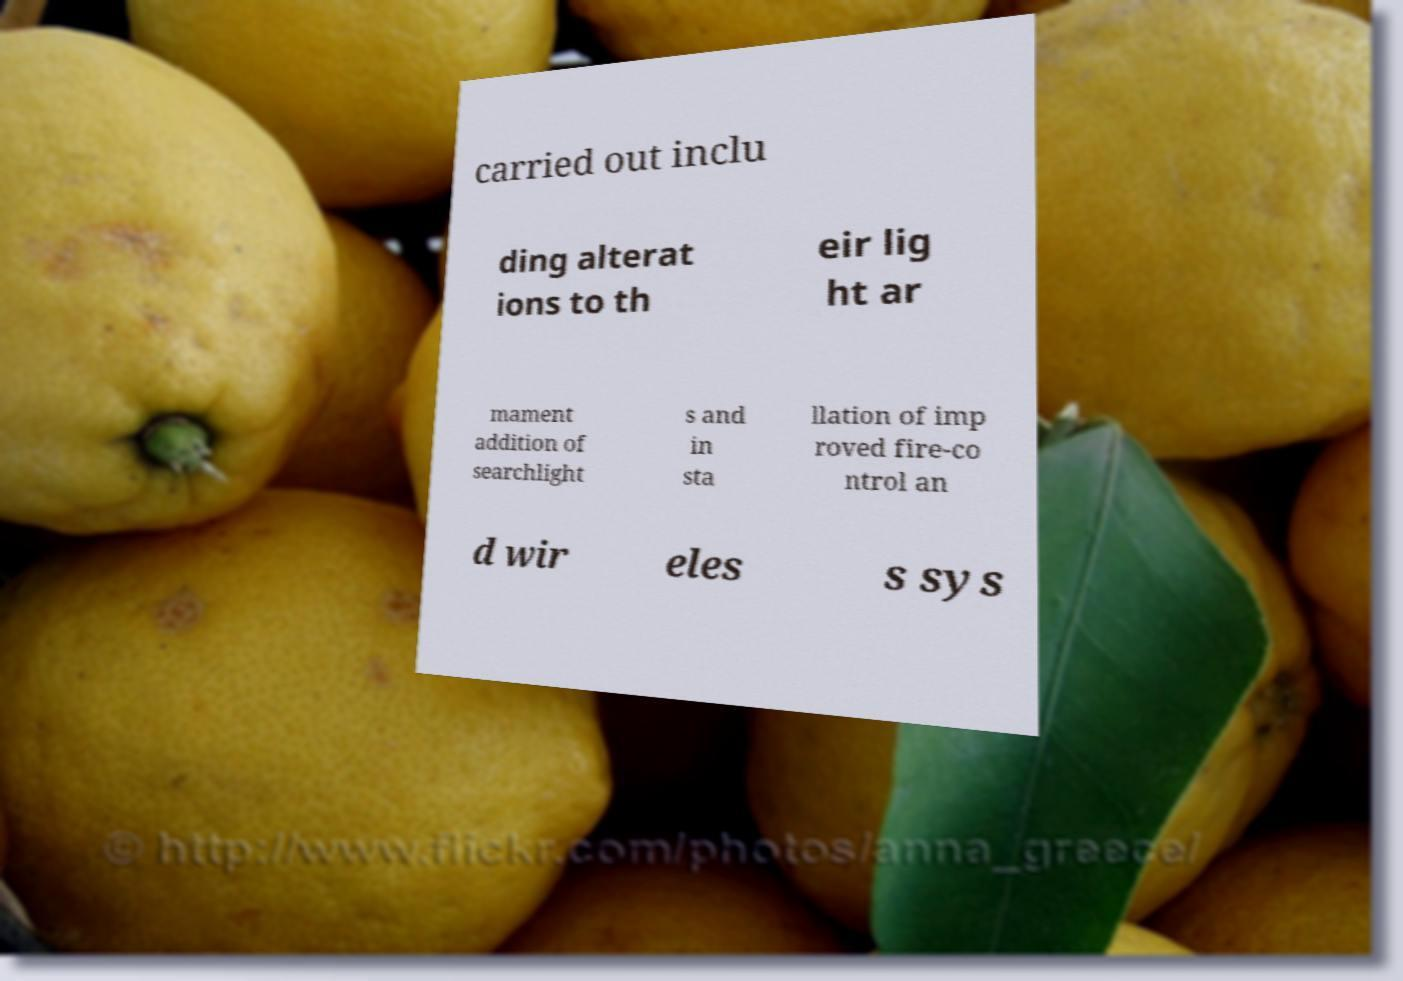Please read and relay the text visible in this image. What does it say? carried out inclu ding alterat ions to th eir lig ht ar mament addition of searchlight s and in sta llation of imp roved fire-co ntrol an d wir eles s sys 